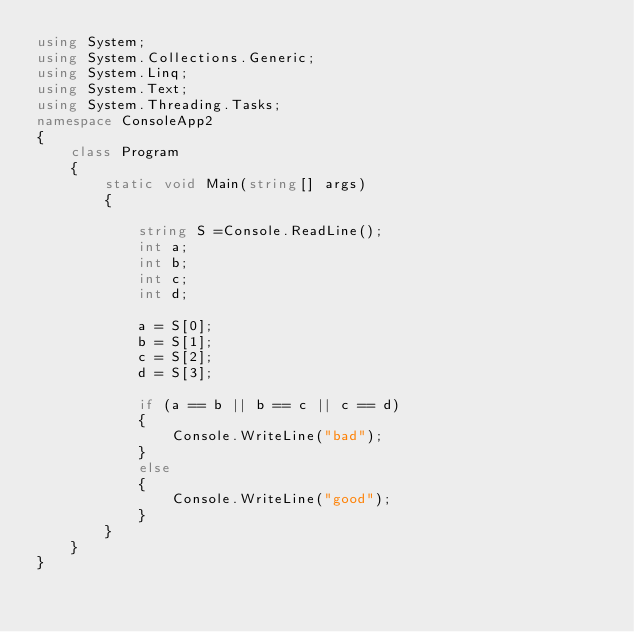<code> <loc_0><loc_0><loc_500><loc_500><_C#_>using System;
using System.Collections.Generic;
using System.Linq;
using System.Text;
using System.Threading.Tasks;
namespace ConsoleApp2
{
    class Program
    {
        static void Main(string[] args)
        {

            string S =Console.ReadLine();
            int a;
            int b;
            int c;
            int d;

            a = S[0];
            b = S[1];
            c = S[2];
            d = S[3];

            if (a == b || b == c || c == d)
            {
                Console.WriteLine("bad");
            }
            else
            {
                Console.WriteLine("good");
            }
        }
    }
}</code> 